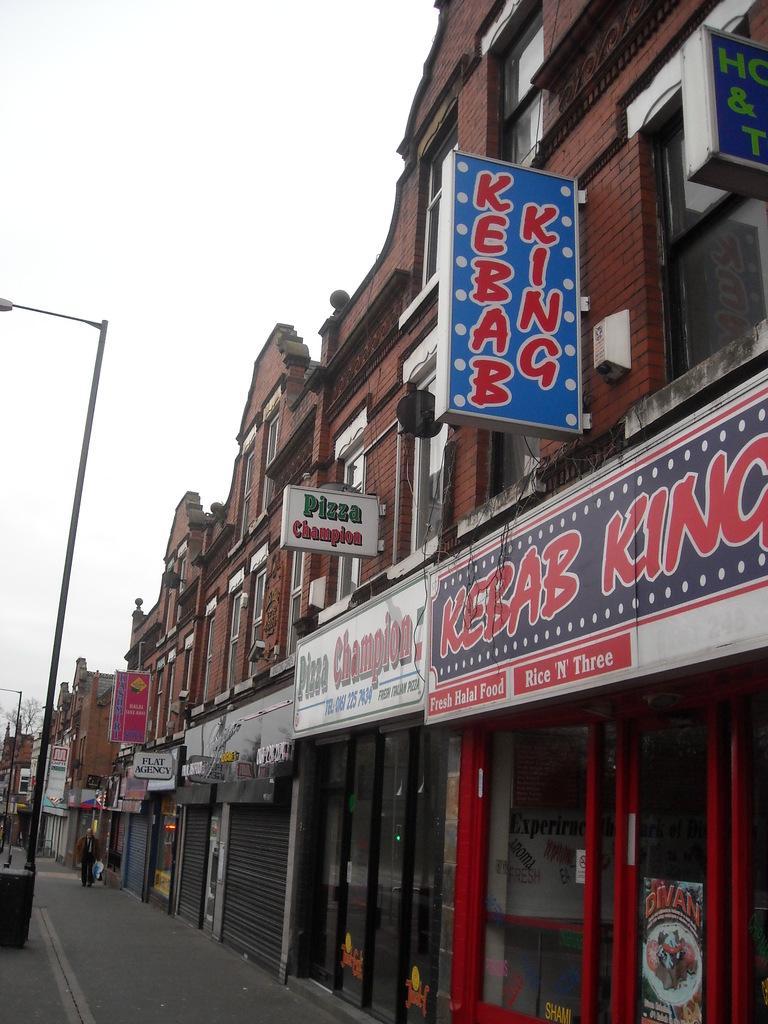In one or two sentences, can you explain what this image depicts? In this image in the right there are many buildings and hoardings. In the left there are street lights. This is a path. There is a person. The sky is clear. 